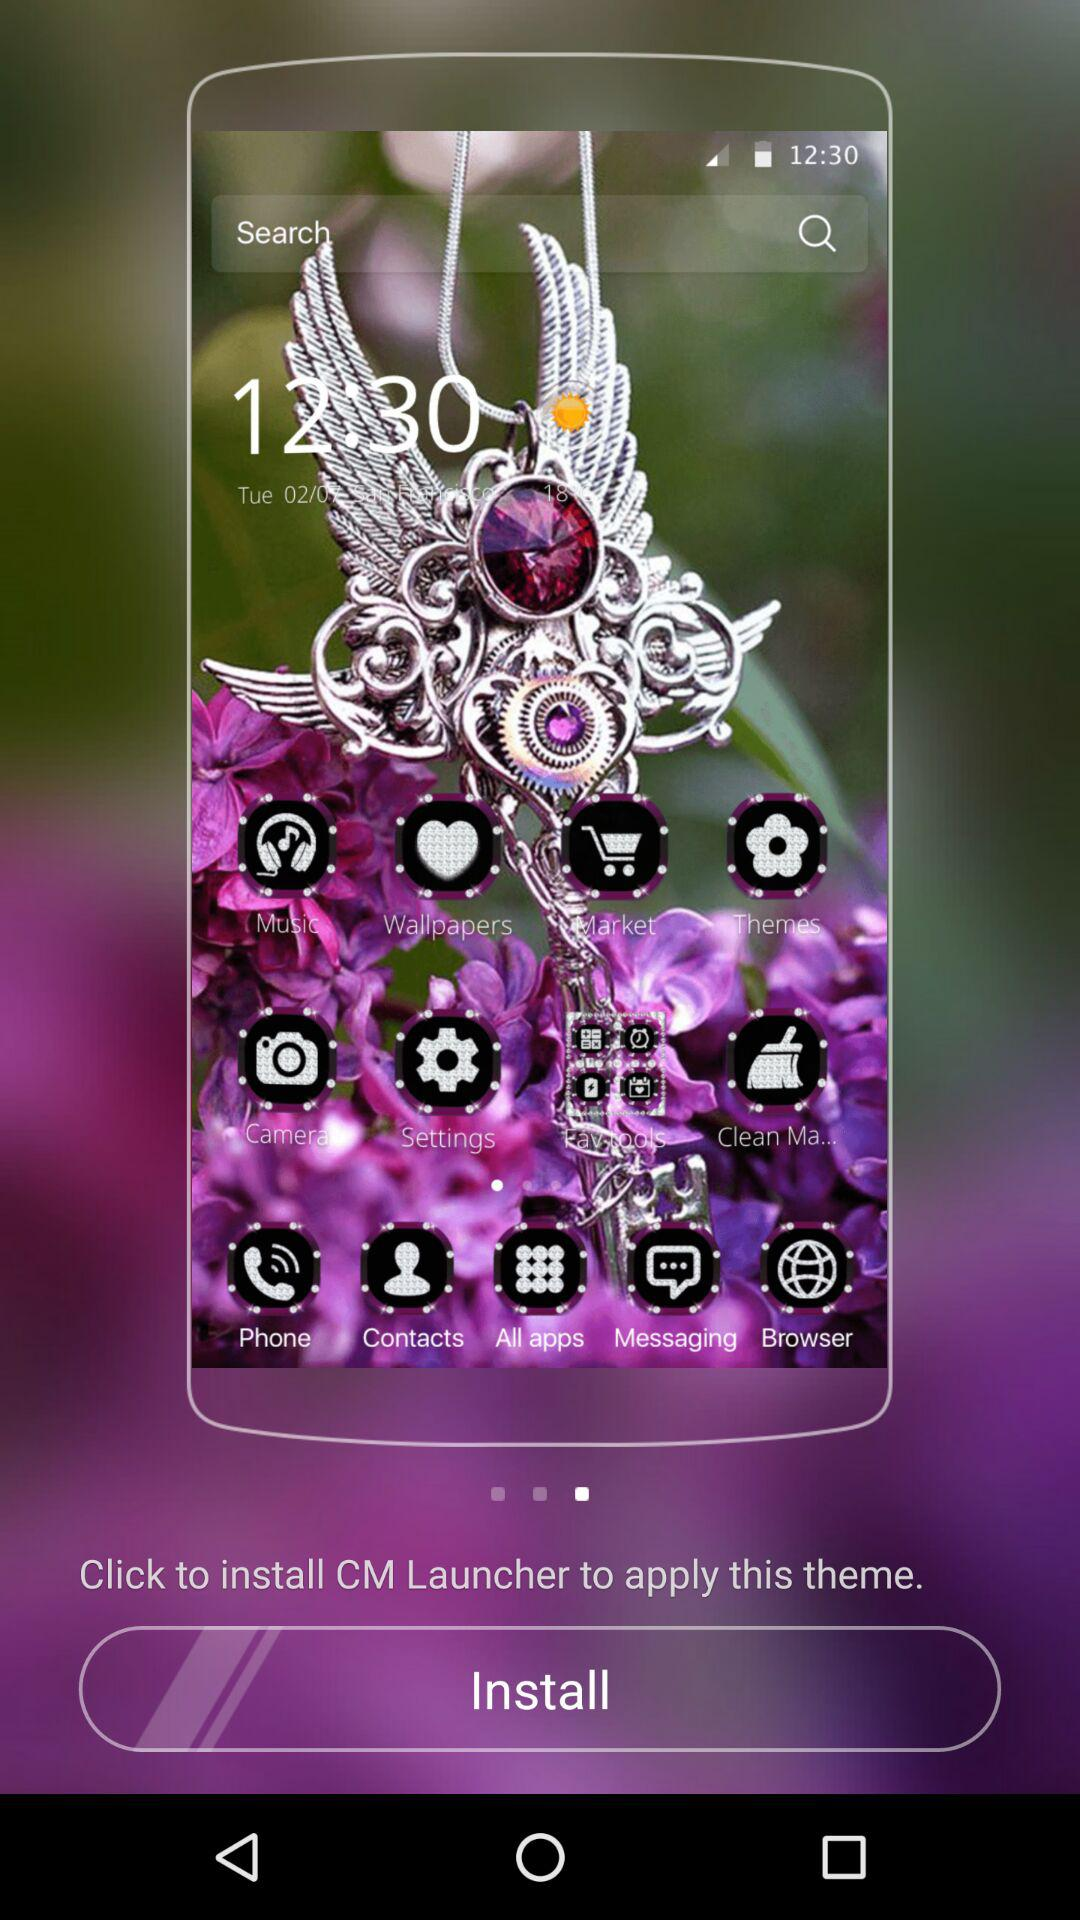What is the name of the theme?
When the provided information is insufficient, respond with <no answer>. <no answer> 